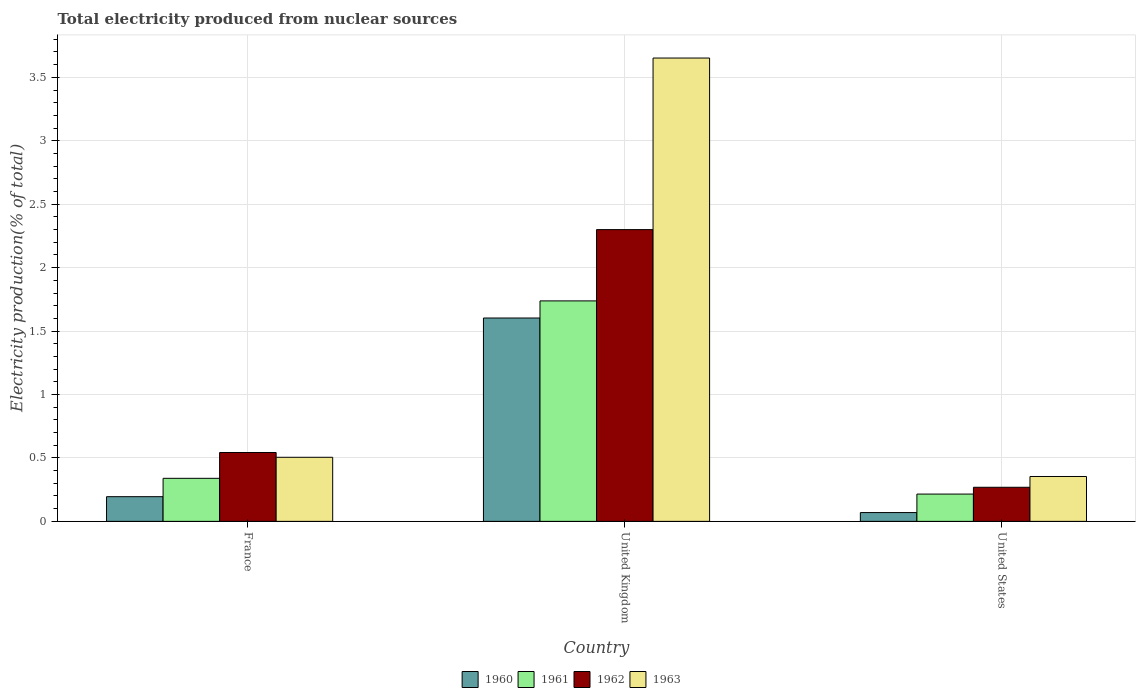How many groups of bars are there?
Provide a succinct answer. 3. Are the number of bars per tick equal to the number of legend labels?
Give a very brief answer. Yes. How many bars are there on the 1st tick from the left?
Your answer should be compact. 4. How many bars are there on the 2nd tick from the right?
Your answer should be compact. 4. In how many cases, is the number of bars for a given country not equal to the number of legend labels?
Your answer should be compact. 0. What is the total electricity produced in 1960 in United States?
Keep it short and to the point. 0.07. Across all countries, what is the maximum total electricity produced in 1961?
Your answer should be compact. 1.74. Across all countries, what is the minimum total electricity produced in 1963?
Ensure brevity in your answer.  0.35. What is the total total electricity produced in 1962 in the graph?
Offer a very short reply. 3.11. What is the difference between the total electricity produced in 1963 in France and that in United States?
Your answer should be very brief. 0.15. What is the difference between the total electricity produced in 1961 in United Kingdom and the total electricity produced in 1963 in France?
Your response must be concise. 1.23. What is the average total electricity produced in 1962 per country?
Your response must be concise. 1.04. What is the difference between the total electricity produced of/in 1960 and total electricity produced of/in 1963 in United Kingdom?
Give a very brief answer. -2.05. In how many countries, is the total electricity produced in 1963 greater than 2.7 %?
Your answer should be compact. 1. What is the ratio of the total electricity produced in 1961 in United Kingdom to that in United States?
Your answer should be very brief. 8.08. Is the total electricity produced in 1962 in United Kingdom less than that in United States?
Give a very brief answer. No. Is the difference between the total electricity produced in 1960 in France and United States greater than the difference between the total electricity produced in 1963 in France and United States?
Your response must be concise. No. What is the difference between the highest and the second highest total electricity produced in 1960?
Your response must be concise. -1.41. What is the difference between the highest and the lowest total electricity produced in 1960?
Your answer should be very brief. 1.53. In how many countries, is the total electricity produced in 1960 greater than the average total electricity produced in 1960 taken over all countries?
Your response must be concise. 1. Is the sum of the total electricity produced in 1962 in United Kingdom and United States greater than the maximum total electricity produced in 1960 across all countries?
Provide a succinct answer. Yes. Is it the case that in every country, the sum of the total electricity produced in 1960 and total electricity produced in 1962 is greater than the sum of total electricity produced in 1963 and total electricity produced in 1961?
Your response must be concise. No. What does the 3rd bar from the left in France represents?
Make the answer very short. 1962. What does the 4th bar from the right in United States represents?
Provide a succinct answer. 1960. How many countries are there in the graph?
Provide a short and direct response. 3. What is the difference between two consecutive major ticks on the Y-axis?
Give a very brief answer. 0.5. Are the values on the major ticks of Y-axis written in scientific E-notation?
Your answer should be compact. No. Does the graph contain any zero values?
Keep it short and to the point. No. Does the graph contain grids?
Give a very brief answer. Yes. Where does the legend appear in the graph?
Offer a terse response. Bottom center. How many legend labels are there?
Offer a terse response. 4. What is the title of the graph?
Offer a very short reply. Total electricity produced from nuclear sources. What is the label or title of the X-axis?
Your answer should be very brief. Country. What is the Electricity production(% of total) in 1960 in France?
Make the answer very short. 0.19. What is the Electricity production(% of total) of 1961 in France?
Your answer should be compact. 0.34. What is the Electricity production(% of total) in 1962 in France?
Provide a short and direct response. 0.54. What is the Electricity production(% of total) of 1963 in France?
Provide a short and direct response. 0.51. What is the Electricity production(% of total) in 1960 in United Kingdom?
Keep it short and to the point. 1.6. What is the Electricity production(% of total) of 1961 in United Kingdom?
Offer a very short reply. 1.74. What is the Electricity production(% of total) in 1962 in United Kingdom?
Your answer should be compact. 2.3. What is the Electricity production(% of total) of 1963 in United Kingdom?
Your response must be concise. 3.65. What is the Electricity production(% of total) in 1960 in United States?
Give a very brief answer. 0.07. What is the Electricity production(% of total) of 1961 in United States?
Provide a succinct answer. 0.22. What is the Electricity production(% of total) of 1962 in United States?
Provide a succinct answer. 0.27. What is the Electricity production(% of total) in 1963 in United States?
Make the answer very short. 0.35. Across all countries, what is the maximum Electricity production(% of total) of 1960?
Make the answer very short. 1.6. Across all countries, what is the maximum Electricity production(% of total) of 1961?
Keep it short and to the point. 1.74. Across all countries, what is the maximum Electricity production(% of total) of 1962?
Your response must be concise. 2.3. Across all countries, what is the maximum Electricity production(% of total) of 1963?
Make the answer very short. 3.65. Across all countries, what is the minimum Electricity production(% of total) in 1960?
Keep it short and to the point. 0.07. Across all countries, what is the minimum Electricity production(% of total) in 1961?
Your answer should be compact. 0.22. Across all countries, what is the minimum Electricity production(% of total) of 1962?
Ensure brevity in your answer.  0.27. Across all countries, what is the minimum Electricity production(% of total) of 1963?
Your response must be concise. 0.35. What is the total Electricity production(% of total) of 1960 in the graph?
Offer a terse response. 1.87. What is the total Electricity production(% of total) in 1961 in the graph?
Give a very brief answer. 2.29. What is the total Electricity production(% of total) of 1962 in the graph?
Provide a succinct answer. 3.11. What is the total Electricity production(% of total) in 1963 in the graph?
Make the answer very short. 4.51. What is the difference between the Electricity production(% of total) in 1960 in France and that in United Kingdom?
Offer a terse response. -1.41. What is the difference between the Electricity production(% of total) in 1961 in France and that in United Kingdom?
Your answer should be compact. -1.4. What is the difference between the Electricity production(% of total) in 1962 in France and that in United Kingdom?
Your answer should be very brief. -1.76. What is the difference between the Electricity production(% of total) in 1963 in France and that in United Kingdom?
Give a very brief answer. -3.15. What is the difference between the Electricity production(% of total) in 1960 in France and that in United States?
Ensure brevity in your answer.  0.13. What is the difference between the Electricity production(% of total) of 1961 in France and that in United States?
Offer a very short reply. 0.12. What is the difference between the Electricity production(% of total) of 1962 in France and that in United States?
Ensure brevity in your answer.  0.27. What is the difference between the Electricity production(% of total) of 1963 in France and that in United States?
Your answer should be compact. 0.15. What is the difference between the Electricity production(% of total) of 1960 in United Kingdom and that in United States?
Give a very brief answer. 1.53. What is the difference between the Electricity production(% of total) in 1961 in United Kingdom and that in United States?
Offer a terse response. 1.52. What is the difference between the Electricity production(% of total) in 1962 in United Kingdom and that in United States?
Your response must be concise. 2.03. What is the difference between the Electricity production(% of total) in 1963 in United Kingdom and that in United States?
Your answer should be compact. 3.3. What is the difference between the Electricity production(% of total) in 1960 in France and the Electricity production(% of total) in 1961 in United Kingdom?
Your answer should be compact. -1.54. What is the difference between the Electricity production(% of total) in 1960 in France and the Electricity production(% of total) in 1962 in United Kingdom?
Your answer should be very brief. -2.11. What is the difference between the Electricity production(% of total) of 1960 in France and the Electricity production(% of total) of 1963 in United Kingdom?
Keep it short and to the point. -3.46. What is the difference between the Electricity production(% of total) in 1961 in France and the Electricity production(% of total) in 1962 in United Kingdom?
Give a very brief answer. -1.96. What is the difference between the Electricity production(% of total) of 1961 in France and the Electricity production(% of total) of 1963 in United Kingdom?
Give a very brief answer. -3.31. What is the difference between the Electricity production(% of total) in 1962 in France and the Electricity production(% of total) in 1963 in United Kingdom?
Make the answer very short. -3.11. What is the difference between the Electricity production(% of total) in 1960 in France and the Electricity production(% of total) in 1961 in United States?
Provide a short and direct response. -0.02. What is the difference between the Electricity production(% of total) in 1960 in France and the Electricity production(% of total) in 1962 in United States?
Provide a short and direct response. -0.07. What is the difference between the Electricity production(% of total) of 1960 in France and the Electricity production(% of total) of 1963 in United States?
Offer a terse response. -0.16. What is the difference between the Electricity production(% of total) in 1961 in France and the Electricity production(% of total) in 1962 in United States?
Keep it short and to the point. 0.07. What is the difference between the Electricity production(% of total) of 1961 in France and the Electricity production(% of total) of 1963 in United States?
Your answer should be compact. -0.01. What is the difference between the Electricity production(% of total) of 1962 in France and the Electricity production(% of total) of 1963 in United States?
Offer a very short reply. 0.19. What is the difference between the Electricity production(% of total) in 1960 in United Kingdom and the Electricity production(% of total) in 1961 in United States?
Provide a short and direct response. 1.39. What is the difference between the Electricity production(% of total) in 1960 in United Kingdom and the Electricity production(% of total) in 1962 in United States?
Offer a terse response. 1.33. What is the difference between the Electricity production(% of total) of 1960 in United Kingdom and the Electricity production(% of total) of 1963 in United States?
Give a very brief answer. 1.25. What is the difference between the Electricity production(% of total) of 1961 in United Kingdom and the Electricity production(% of total) of 1962 in United States?
Your answer should be compact. 1.47. What is the difference between the Electricity production(% of total) of 1961 in United Kingdom and the Electricity production(% of total) of 1963 in United States?
Ensure brevity in your answer.  1.38. What is the difference between the Electricity production(% of total) of 1962 in United Kingdom and the Electricity production(% of total) of 1963 in United States?
Your answer should be very brief. 1.95. What is the average Electricity production(% of total) in 1960 per country?
Ensure brevity in your answer.  0.62. What is the average Electricity production(% of total) in 1961 per country?
Keep it short and to the point. 0.76. What is the average Electricity production(% of total) of 1963 per country?
Offer a very short reply. 1.5. What is the difference between the Electricity production(% of total) in 1960 and Electricity production(% of total) in 1961 in France?
Ensure brevity in your answer.  -0.14. What is the difference between the Electricity production(% of total) of 1960 and Electricity production(% of total) of 1962 in France?
Provide a succinct answer. -0.35. What is the difference between the Electricity production(% of total) in 1960 and Electricity production(% of total) in 1963 in France?
Keep it short and to the point. -0.31. What is the difference between the Electricity production(% of total) of 1961 and Electricity production(% of total) of 1962 in France?
Your answer should be very brief. -0.2. What is the difference between the Electricity production(% of total) of 1961 and Electricity production(% of total) of 1963 in France?
Ensure brevity in your answer.  -0.17. What is the difference between the Electricity production(% of total) in 1962 and Electricity production(% of total) in 1963 in France?
Ensure brevity in your answer.  0.04. What is the difference between the Electricity production(% of total) of 1960 and Electricity production(% of total) of 1961 in United Kingdom?
Offer a terse response. -0.13. What is the difference between the Electricity production(% of total) of 1960 and Electricity production(% of total) of 1962 in United Kingdom?
Your response must be concise. -0.7. What is the difference between the Electricity production(% of total) of 1960 and Electricity production(% of total) of 1963 in United Kingdom?
Provide a short and direct response. -2.05. What is the difference between the Electricity production(% of total) of 1961 and Electricity production(% of total) of 1962 in United Kingdom?
Keep it short and to the point. -0.56. What is the difference between the Electricity production(% of total) in 1961 and Electricity production(% of total) in 1963 in United Kingdom?
Your response must be concise. -1.91. What is the difference between the Electricity production(% of total) in 1962 and Electricity production(% of total) in 1963 in United Kingdom?
Your answer should be compact. -1.35. What is the difference between the Electricity production(% of total) of 1960 and Electricity production(% of total) of 1961 in United States?
Your answer should be very brief. -0.15. What is the difference between the Electricity production(% of total) in 1960 and Electricity production(% of total) in 1962 in United States?
Provide a short and direct response. -0.2. What is the difference between the Electricity production(% of total) in 1960 and Electricity production(% of total) in 1963 in United States?
Offer a terse response. -0.28. What is the difference between the Electricity production(% of total) of 1961 and Electricity production(% of total) of 1962 in United States?
Give a very brief answer. -0.05. What is the difference between the Electricity production(% of total) in 1961 and Electricity production(% of total) in 1963 in United States?
Provide a succinct answer. -0.14. What is the difference between the Electricity production(% of total) of 1962 and Electricity production(% of total) of 1963 in United States?
Give a very brief answer. -0.09. What is the ratio of the Electricity production(% of total) of 1960 in France to that in United Kingdom?
Make the answer very short. 0.12. What is the ratio of the Electricity production(% of total) of 1961 in France to that in United Kingdom?
Your response must be concise. 0.2. What is the ratio of the Electricity production(% of total) of 1962 in France to that in United Kingdom?
Provide a succinct answer. 0.24. What is the ratio of the Electricity production(% of total) in 1963 in France to that in United Kingdom?
Offer a terse response. 0.14. What is the ratio of the Electricity production(% of total) in 1960 in France to that in United States?
Give a very brief answer. 2.81. What is the ratio of the Electricity production(% of total) in 1961 in France to that in United States?
Your response must be concise. 1.58. What is the ratio of the Electricity production(% of total) in 1962 in France to that in United States?
Keep it short and to the point. 2.02. What is the ratio of the Electricity production(% of total) of 1963 in France to that in United States?
Offer a very short reply. 1.43. What is the ratio of the Electricity production(% of total) in 1960 in United Kingdom to that in United States?
Provide a succinct answer. 23.14. What is the ratio of the Electricity production(% of total) in 1961 in United Kingdom to that in United States?
Give a very brief answer. 8.08. What is the ratio of the Electricity production(% of total) of 1962 in United Kingdom to that in United States?
Your answer should be very brief. 8.56. What is the ratio of the Electricity production(% of total) in 1963 in United Kingdom to that in United States?
Your response must be concise. 10.32. What is the difference between the highest and the second highest Electricity production(% of total) of 1960?
Offer a very short reply. 1.41. What is the difference between the highest and the second highest Electricity production(% of total) in 1961?
Offer a very short reply. 1.4. What is the difference between the highest and the second highest Electricity production(% of total) in 1962?
Provide a succinct answer. 1.76. What is the difference between the highest and the second highest Electricity production(% of total) of 1963?
Your response must be concise. 3.15. What is the difference between the highest and the lowest Electricity production(% of total) of 1960?
Offer a terse response. 1.53. What is the difference between the highest and the lowest Electricity production(% of total) in 1961?
Your response must be concise. 1.52. What is the difference between the highest and the lowest Electricity production(% of total) of 1962?
Offer a very short reply. 2.03. What is the difference between the highest and the lowest Electricity production(% of total) of 1963?
Give a very brief answer. 3.3. 